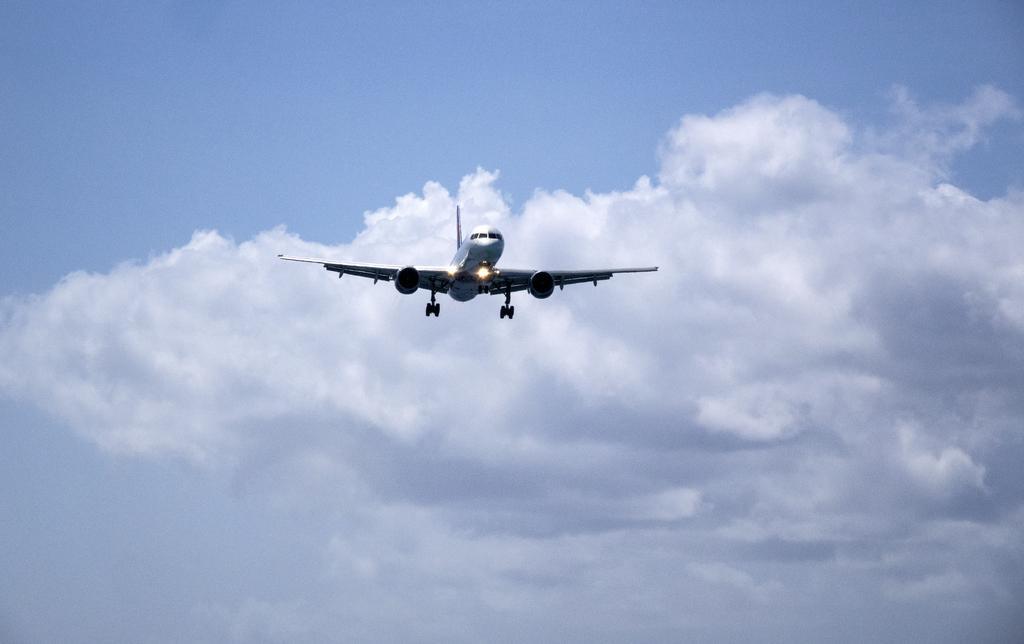How would you summarize this image in a sentence or two? In this image we can see an airplane which is in white color is flying in the sky and we can see some clouds and blue color sky. 